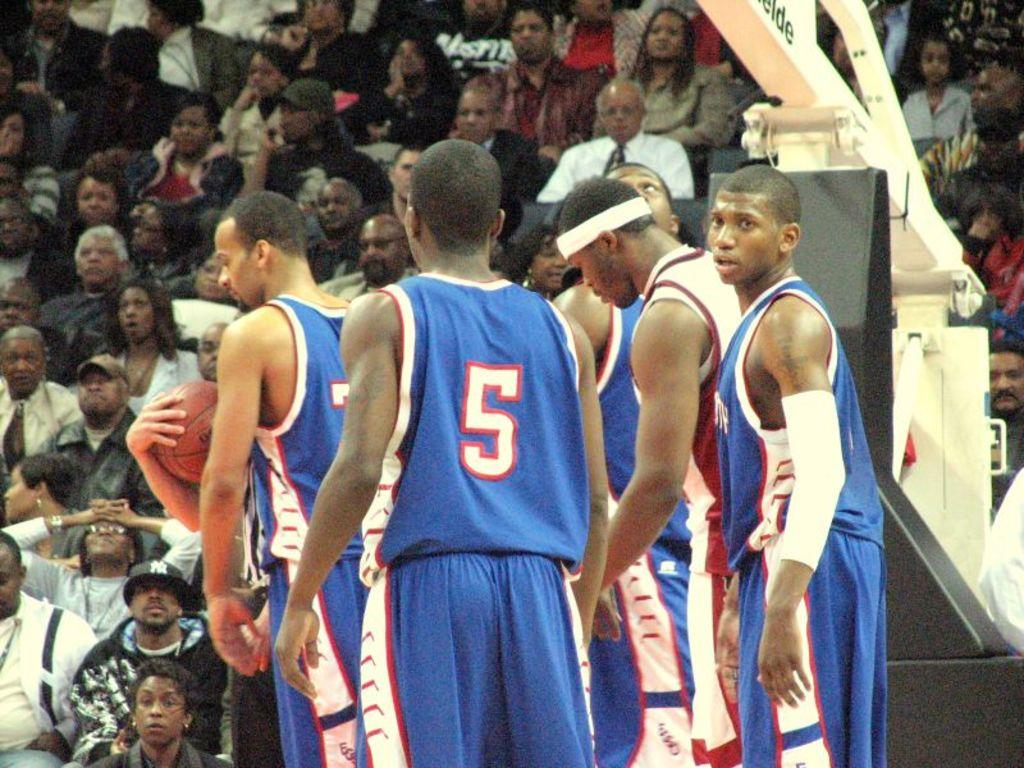Provide a one-sentence caption for the provided image. A basketball player in a number 5 uniform stands near his teammates on the court. 